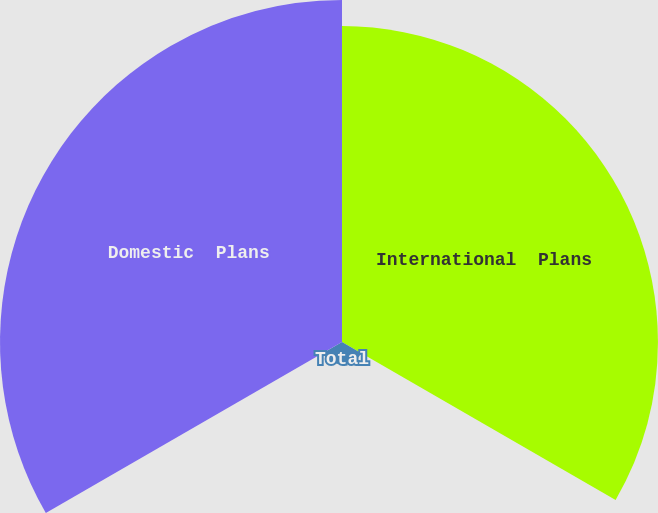<chart> <loc_0><loc_0><loc_500><loc_500><pie_chart><fcel>International  Plans<fcel>Total<fcel>Domestic  Plans<nl><fcel>46.44%<fcel>3.29%<fcel>50.27%<nl></chart> 